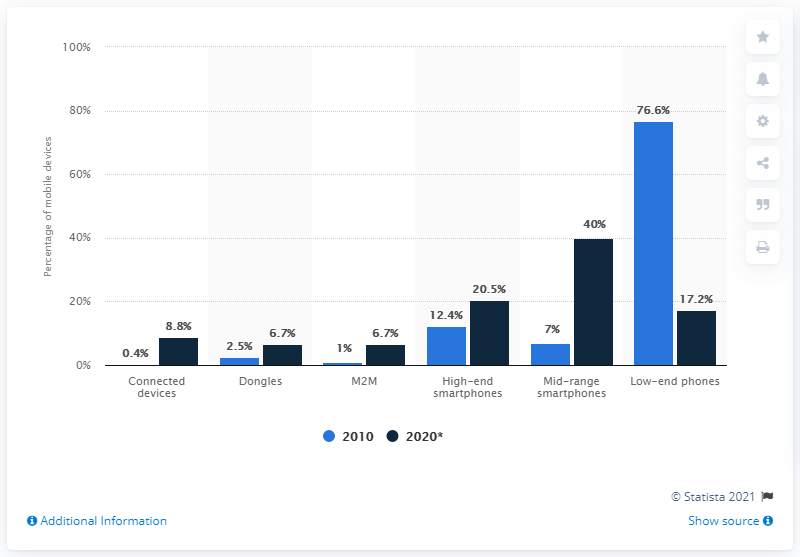Identify some key points in this picture. In 2010, low-end mobile devices accounted for 76.6% of the total market share of mobile devices. 